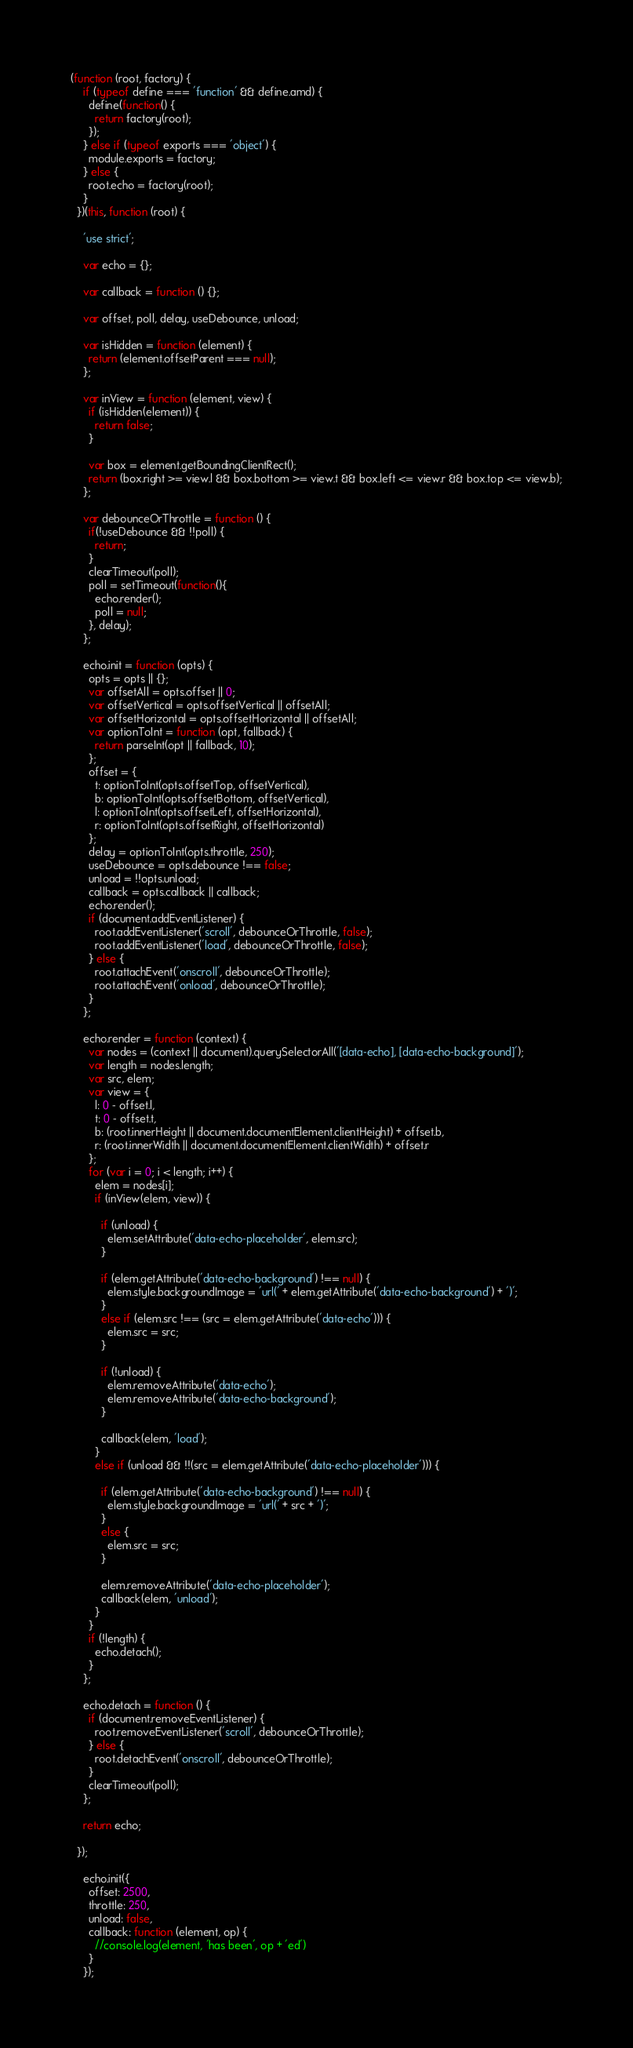<code> <loc_0><loc_0><loc_500><loc_500><_JavaScript_>(function (root, factory) {
    if (typeof define === 'function' && define.amd) {
      define(function() {
        return factory(root);
      });
    } else if (typeof exports === 'object') {
      module.exports = factory;
    } else {
      root.echo = factory(root);
    }
  })(this, function (root) {
  
    'use strict';
  
    var echo = {};
  
    var callback = function () {};
  
    var offset, poll, delay, useDebounce, unload;
  
    var isHidden = function (element) {
      return (element.offsetParent === null);
    };
    
    var inView = function (element, view) {
      if (isHidden(element)) {
        return false;
      }
  
      var box = element.getBoundingClientRect();
      return (box.right >= view.l && box.bottom >= view.t && box.left <= view.r && box.top <= view.b);
    };
  
    var debounceOrThrottle = function () {
      if(!useDebounce && !!poll) {
        return;
      }
      clearTimeout(poll);
      poll = setTimeout(function(){
        echo.render();
        poll = null;
      }, delay);
    };
  
    echo.init = function (opts) {
      opts = opts || {};
      var offsetAll = opts.offset || 0;
      var offsetVertical = opts.offsetVertical || offsetAll;
      var offsetHorizontal = opts.offsetHorizontal || offsetAll;
      var optionToInt = function (opt, fallback) {
        return parseInt(opt || fallback, 10);
      };
      offset = {
        t: optionToInt(opts.offsetTop, offsetVertical),
        b: optionToInt(opts.offsetBottom, offsetVertical),
        l: optionToInt(opts.offsetLeft, offsetHorizontal),
        r: optionToInt(opts.offsetRight, offsetHorizontal)
      };
      delay = optionToInt(opts.throttle, 250);
      useDebounce = opts.debounce !== false;
      unload = !!opts.unload;
      callback = opts.callback || callback;
      echo.render();
      if (document.addEventListener) {
        root.addEventListener('scroll', debounceOrThrottle, false);
        root.addEventListener('load', debounceOrThrottle, false);
      } else {
        root.attachEvent('onscroll', debounceOrThrottle);
        root.attachEvent('onload', debounceOrThrottle);
      }
    };
  
    echo.render = function (context) {
      var nodes = (context || document).querySelectorAll('[data-echo], [data-echo-background]');
      var length = nodes.length;
      var src, elem;
      var view = {
        l: 0 - offset.l,
        t: 0 - offset.t,
        b: (root.innerHeight || document.documentElement.clientHeight) + offset.b,
        r: (root.innerWidth || document.documentElement.clientWidth) + offset.r
      };
      for (var i = 0; i < length; i++) {
        elem = nodes[i];
        if (inView(elem, view)) {
  
          if (unload) {
            elem.setAttribute('data-echo-placeholder', elem.src);
          }
  
          if (elem.getAttribute('data-echo-background') !== null) {
            elem.style.backgroundImage = 'url(' + elem.getAttribute('data-echo-background') + ')';
          }
          else if (elem.src !== (src = elem.getAttribute('data-echo'))) {
            elem.src = src;
          }
  
          if (!unload) {
            elem.removeAttribute('data-echo');
            elem.removeAttribute('data-echo-background');
          }
  
          callback(elem, 'load');
        }
        else if (unload && !!(src = elem.getAttribute('data-echo-placeholder'))) {
  
          if (elem.getAttribute('data-echo-background') !== null) {
            elem.style.backgroundImage = 'url(' + src + ')';
          }
          else {
            elem.src = src;
          }
  
          elem.removeAttribute('data-echo-placeholder');
          callback(elem, 'unload');
        }
      }
      if (!length) {
        echo.detach();
      }
    };
  
    echo.detach = function () {
      if (document.removeEventListener) {
        root.removeEventListener('scroll', debounceOrThrottle);
      } else {
        root.detachEvent('onscroll', debounceOrThrottle);
      }
      clearTimeout(poll);
    };
  
    return echo;
  
  });

    echo.init({
      offset: 2500,
      throttle: 250,
      unload: false,
      callback: function (element, op) {
        //console.log(element, 'has been', op + 'ed')
      }
    });
</code> 